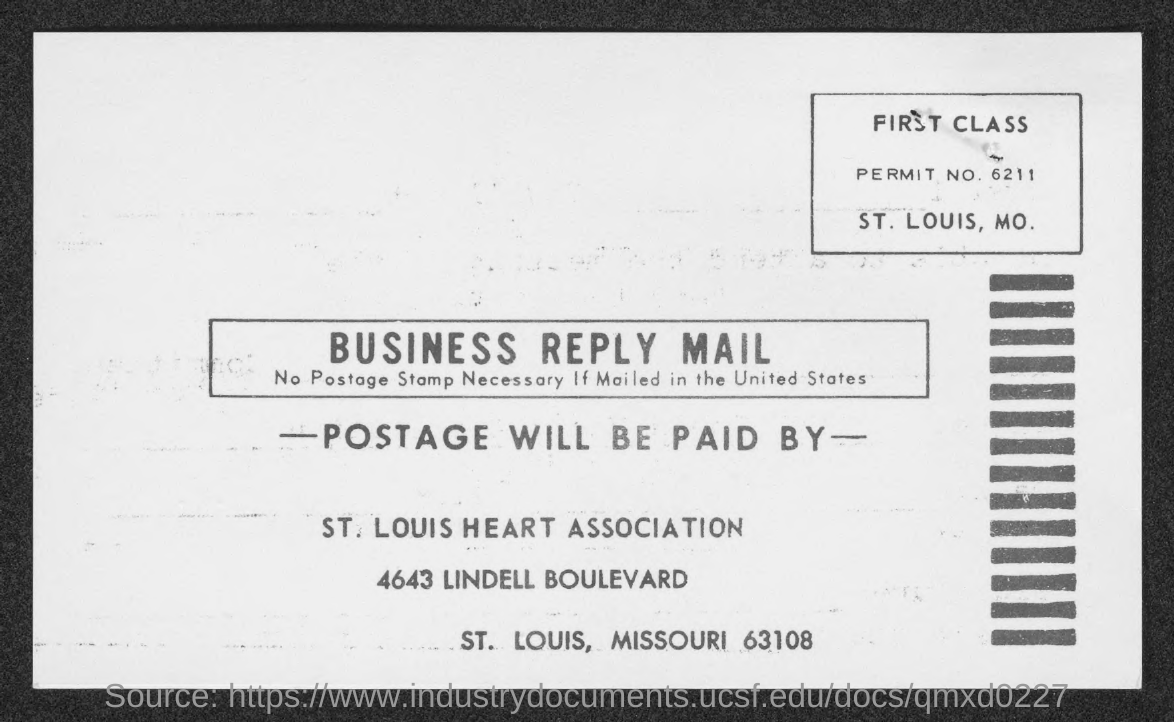What is the permit no.?
Your answer should be compact. 6211. In which county is st . louis heat association at ?
Keep it short and to the point. St. Louis. 